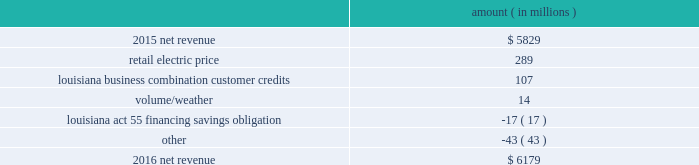( $ 66 million net-of-tax ) as a result of customer credits to be realized by electric customers of entergy louisiana , consistent with the terms of the stipulated settlement in the business combination proceeding .
See note 2 to the financial statements for further discussion of the business combination and customer credits .
Results of operations for 2015 also include the sale in december 2015 of the 583 mw rhode island state energy center for a realized gain of $ 154 million ( $ 100 million net-of-tax ) on the sale and the $ 77 million ( $ 47 million net-of-tax ) write-off and regulatory charges to recognize that a portion of the assets associated with the waterford 3 replacement steam generator project is no longer probable of recovery .
See note 14 to the financial statements for further discussion of the rhode island state energy center sale .
See note 2 to the financial statements for further discussion of the waterford 3 replacement steam generator prudence review proceeding .
Net revenue utility following is an analysis of the change in net revenue comparing 2016 to 2015 .
Amount ( in millions ) .
The retail electric price variance is primarily due to : 2022 an increase in base rates at entergy arkansas , as approved by the apsc .
The new rates were effective february 24 , 2016 and began billing with the first billing cycle of april 2016 .
The increase included an interim base rate adjustment surcharge , effective with the first billing cycle of april 2016 , to recover the incremental revenue requirement for the period february 24 , 2016 through march 31 , 2016 .
A significant portion of the increase was related to the purchase of power block 2 of the union power station ; 2022 an increase in the purchased power and capacity acquisition cost recovery rider for entergy new orleans , as approved by the city council , effective with the first billing cycle of march 2016 , primarily related to the purchase of power block 1 of the union power station ; 2022 an increase in formula rate plan revenues for entergy louisiana , implemented with the first billing cycle of march 2016 , to collect the estimated first-year revenue requirement related to the purchase of power blocks 3 and 4 of the union power station ; and 2022 an increase in revenues at entergy mississippi , as approved by the mpsc , effective with the first billing cycle of july 2016 , and an increase in revenues collected through the storm damage rider .
See note 2 to the financial statements for further discussion of the rate proceedings .
See note 14 to the financial statements for discussion of the union power station purchase .
The louisiana business combination customer credits variance is due to a regulatory liability of $ 107 million recorded by entergy in october 2015 as a result of the entergy gulf states louisiana and entergy louisiana business combination .
Consistent with the terms of the stipulated settlement in the business combination proceeding , electric customers of entergy louisiana will realize customer credits associated with the business combination ; accordingly , in october 2015 , entergy recorded a regulatory liability of $ 107 million ( $ 66 million net-of-tax ) .
These costs are being entergy corporation and subsidiaries management 2019s financial discussion and analysis .
What is the growth rate in net revenue in 2016? 
Computations: ((6179 - 5829) / 5829)
Answer: 0.06004. 